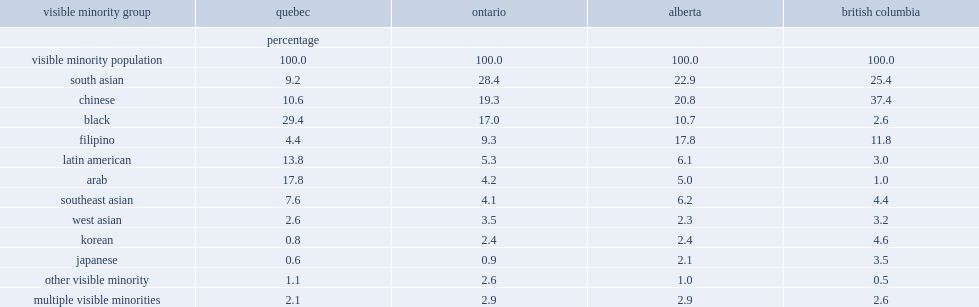In british columbia, the largest visible minority group was chinese, what was the percentage of the female visible minority population in that province? 37.4. In british columbia, the second-largest visible minority group was south asian, what was the percentage of the female visible minority population in that province? 25.4. In british columbia, the third-largest visible minority group was filipino, what was the percentage of the female visible minority population in that province? 11.8. What was the percentage of alberta's largest female visible minority population of south asian? 22.9. What was the percentage of alberta's second-largest female visible minority population of chinese? 20.8. What was the percentage of alberta's third-largest female visible minority population of filipino? 17.8. In ontario, south asian was the largest visible minority group, what was the percentage of the female visible minority population? 28.4. In ontario, chinese was the second-largest visible minority group, what was the percentage of the female visible minority population? 19.3. In ontario, black was the third-largest visible minority group, what was the percentage of the female visible minority population? 17.0. What was the percentage of black females which formed the largest visible minority group in quebec? 29.4. What was the percentage of arab females which formed the second-largest visible minority group in quebec? 17.8. What was the percentage of latin american females which formed the third-largest visible minority group in quebec? 13.8. 